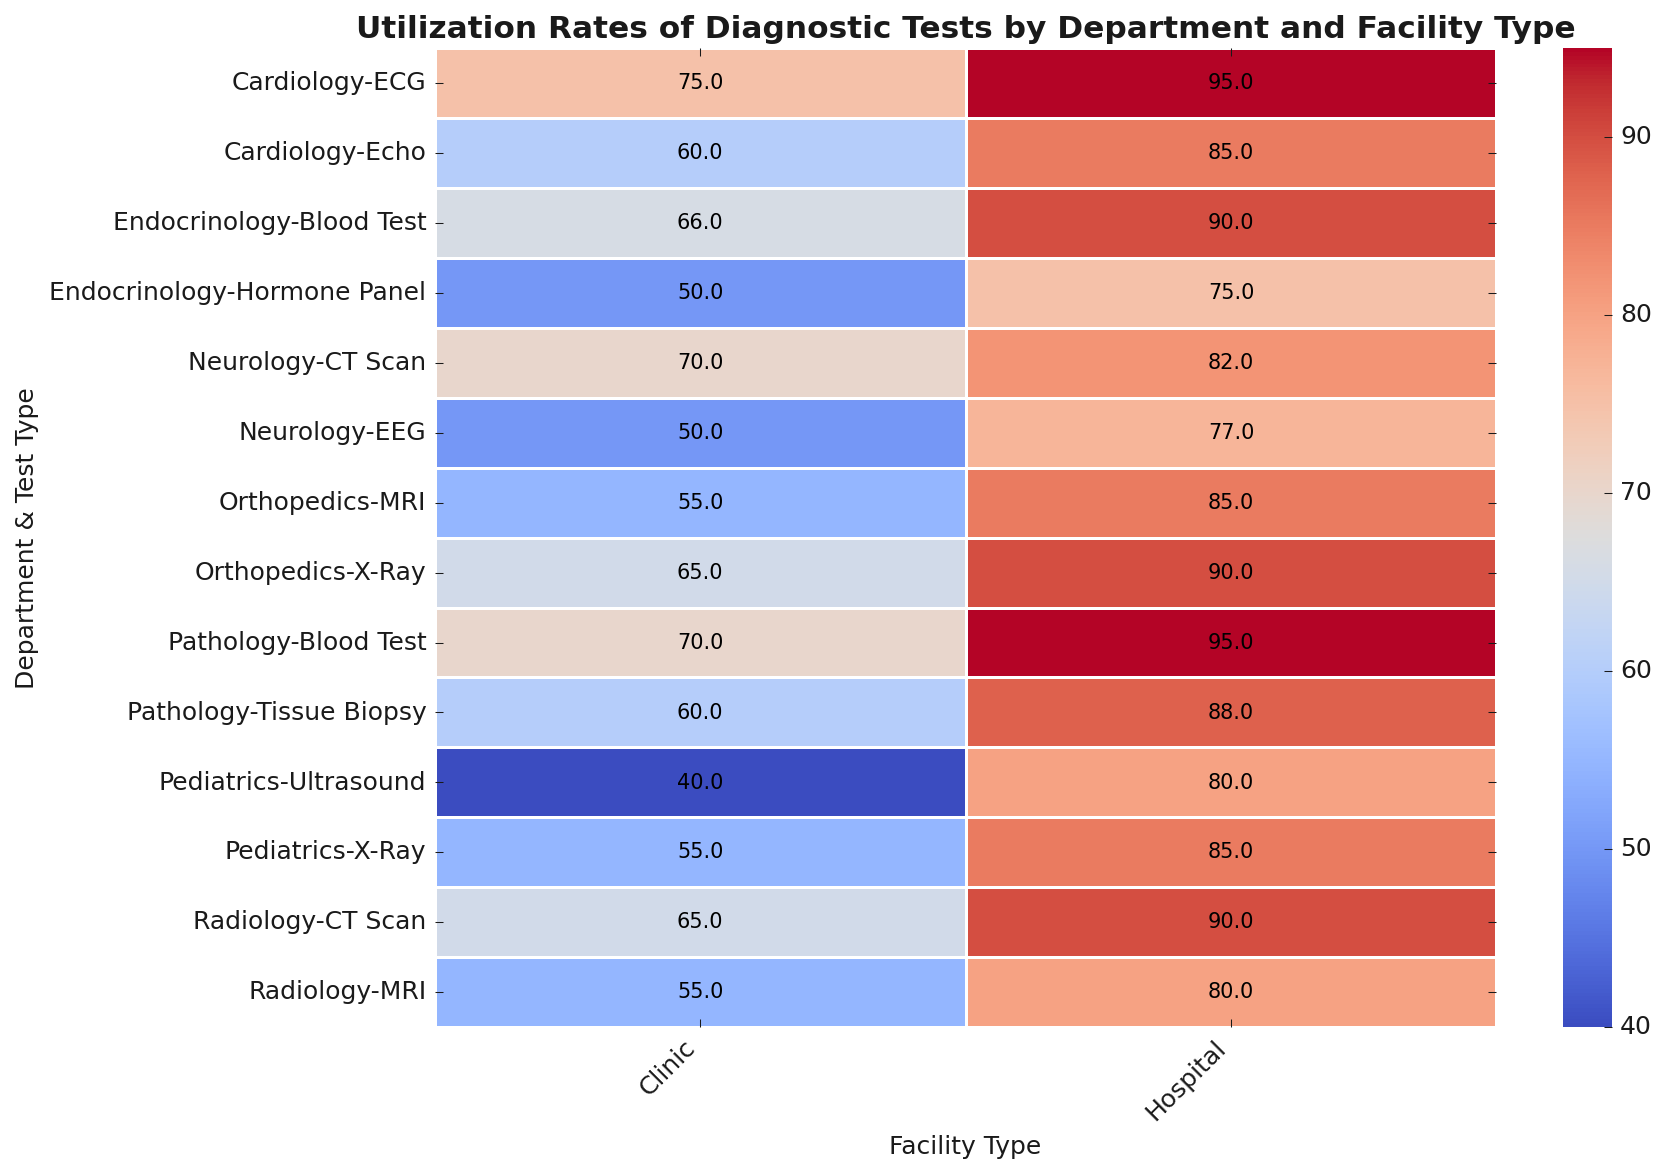Which department has the highest utilization rate for an Echo test in hospitals? Look at the row for Cardiology and the column for Hospital. The utilization rate for Echo in this cell is 85.
Answer: Cardiology How much higher is the utilization rate of MRI in hospitals compared to clinics in Radiology? Find MRI under Radiology for both Hospital and Clinic columns. The rates are 80 and 55, respectively. The difference is 80 - 55 = 25.
Answer: 25 Which test type in Pathology has the largest difference in utilization rates between hospital and clinic? Compare the differences for Blood Test (95 - 70 = 25) and Tissue Biopsy (88 - 60 = 28). Tissue Biopsy has the largest difference of 28.
Answer: Tissue Biopsy What is the average utilization rate of CT Scan tests across all departments in clinics? Locate the CT Scan rows for Neurology and Radiology under the Clinic column. The rates are 70 and 65. Average is (70 + 65) / 2 = 67.5.
Answer: 67.5 Between X-Ray and Ultrasound in Pediatrics at clinics, which test has a lower utilization rate? Check the X-Ray and Ultrasound rates in the Pediatrics Clinic column. X-Ray is 55 and Ultrasound is 40. Ultrasound is lower.
Answer: Ultrasound What is the utilization rate for EEG in Neurology clinics and how does it visually compare to the rate in hospitals? The rate for EEG in Neurology clinics is 50, while hospitals have 77. Visually, this can be seen as a lighter shade of blue in clinics compared to hospitals in the heatmap.
Answer: 50 Which test in Endocrinology hospitals has the higher utilization rate, Blood Test or Hormone Panel? Look under the Endocrinology Hospital column. Blood Test is 90 and Hormone Panel is 75. Blood Test is higher.
Answer: Blood Test What are the utilization rates for Echo tests in both hospitals and clinics in Cardiology? Locate Echo under Cardiology for Hospital and Clinic columns. The rates are 85 and 60, respectively.
Answer: 85 (Hospital), 60 (Clinic) For which test type in Orthopedics clinics is the utilization rate the highest? Look at Orthopedics under the Clinic column and compare rates of X-Ray (65) and MRI (55). X-Ray has the highest rate.
Answer: X-Ray What is the utilization rate difference for Blood Tests between Pathology and Endocrinology in hospitals? Locate Blood Test under Hospital for both Pathology (95) and Endocrinology (90). The difference is 95 - 90 = 5.
Answer: 5 